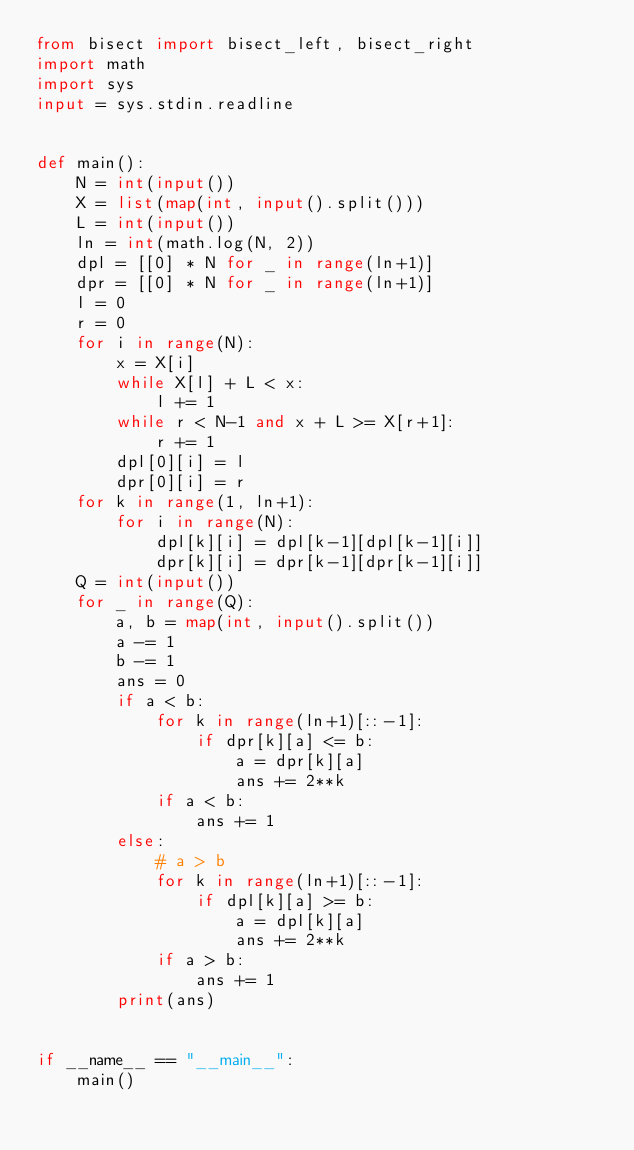Convert code to text. <code><loc_0><loc_0><loc_500><loc_500><_Python_>from bisect import bisect_left, bisect_right
import math
import sys
input = sys.stdin.readline


def main():
    N = int(input())
    X = list(map(int, input().split()))
    L = int(input())
    ln = int(math.log(N, 2))
    dpl = [[0] * N for _ in range(ln+1)]
    dpr = [[0] * N for _ in range(ln+1)]
    l = 0
    r = 0
    for i in range(N):
        x = X[i]
        while X[l] + L < x:
            l += 1
        while r < N-1 and x + L >= X[r+1]:
            r += 1
        dpl[0][i] = l
        dpr[0][i] = r
    for k in range(1, ln+1):
        for i in range(N):
            dpl[k][i] = dpl[k-1][dpl[k-1][i]]
            dpr[k][i] = dpr[k-1][dpr[k-1][i]]
    Q = int(input())
    for _ in range(Q):
        a, b = map(int, input().split())
        a -= 1
        b -= 1
        ans = 0
        if a < b:
            for k in range(ln+1)[::-1]:
                if dpr[k][a] <= b:
                    a = dpr[k][a]
                    ans += 2**k
            if a < b:
                ans += 1
        else:
            # a > b
            for k in range(ln+1)[::-1]:
                if dpl[k][a] >= b:
                    a = dpl[k][a]
                    ans += 2**k
            if a > b:
                ans += 1
        print(ans)


if __name__ == "__main__":
    main()
</code> 